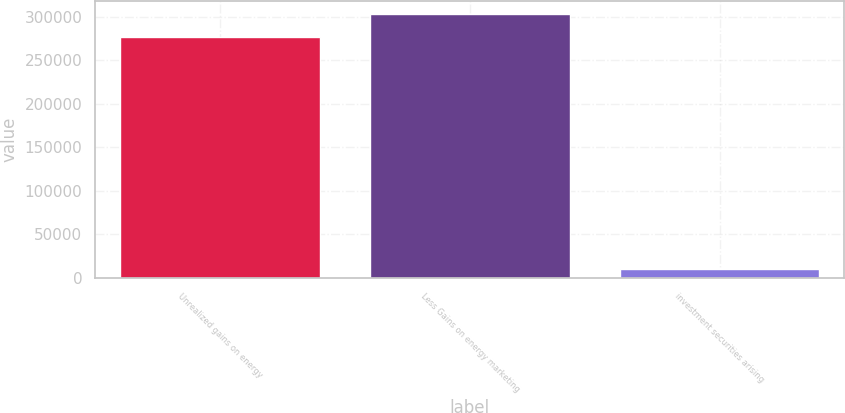<chart> <loc_0><loc_0><loc_500><loc_500><bar_chart><fcel>Unrealized gains on energy<fcel>Less Gains on energy marketing<fcel>investment securities arising<nl><fcel>276400<fcel>303158<fcel>9837<nl></chart> 